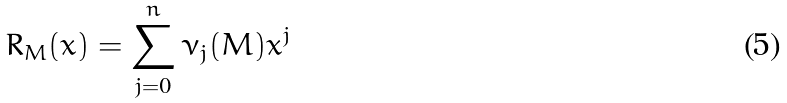<formula> <loc_0><loc_0><loc_500><loc_500>R _ { M } ( x ) = \sum _ { j = 0 } ^ { n } \nu _ { j } ( M ) x ^ { j }</formula> 